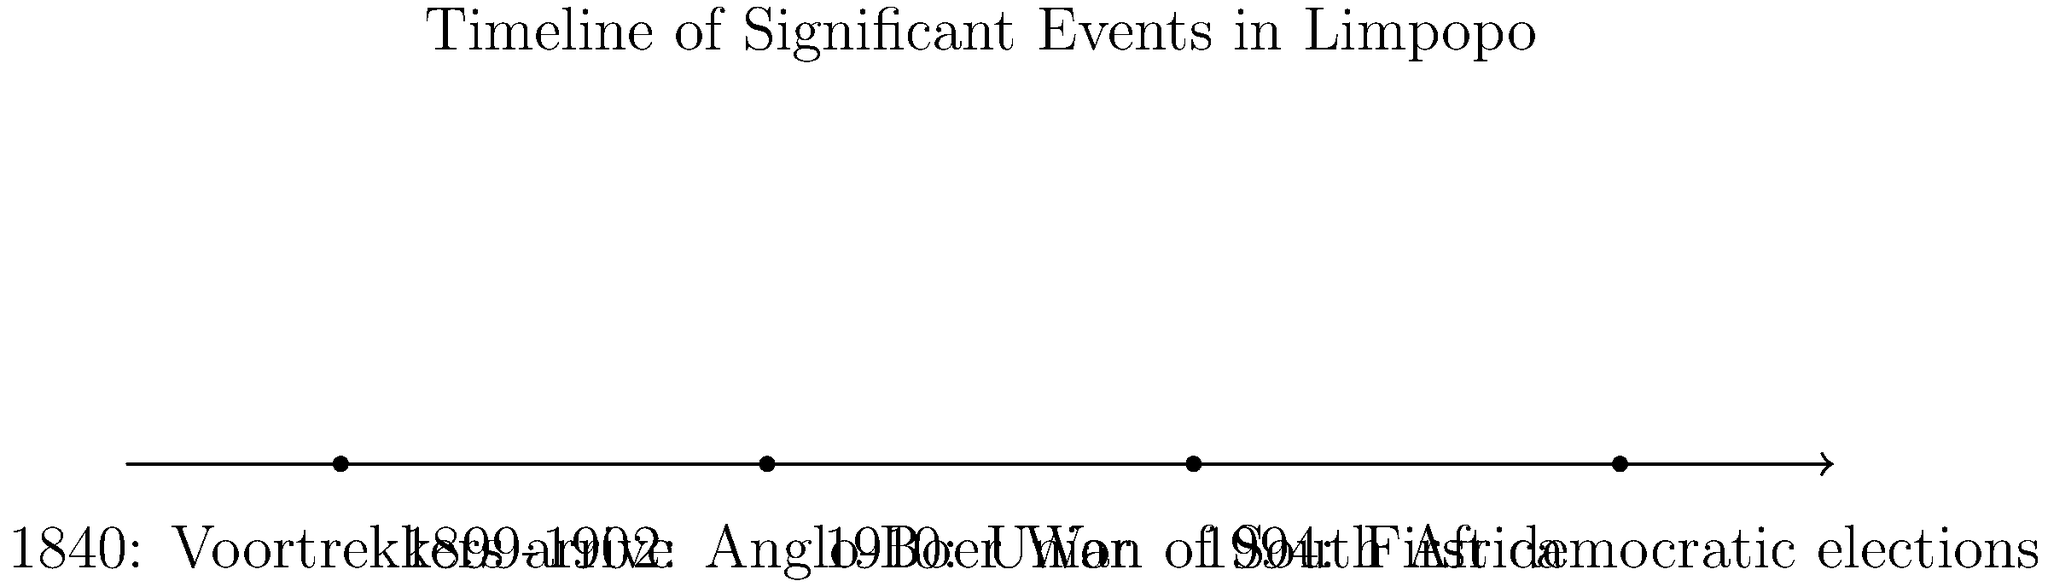Based on the timeline provided, which event marked a significant political change for Limpopo and South Africa as a whole, occurring latest in the chronology? To answer this question, we need to analyze the events on the timeline chronologically:

1. 1840: Voortrekkers arrive - This marks the beginning of European settlement in the area.
2. 1899-1902: Anglo-Boer War - A conflict between British and Boer settlers.
3. 1910: Union of South Africa - The formation of the Union, which excluded black South Africans from political participation.
4. 1994: First democratic elections - This event marked the end of apartheid and the beginning of democratic rule in South Africa.

Among these events, the 1994 First democratic elections represent the most recent and significant political change for both Limpopo and South Africa. This event allowed all South Africans, regardless of race, to participate in the political process for the first time, fundamentally altering the political landscape of the country and its provinces, including Limpopo.
Answer: 1994 First democratic elections 